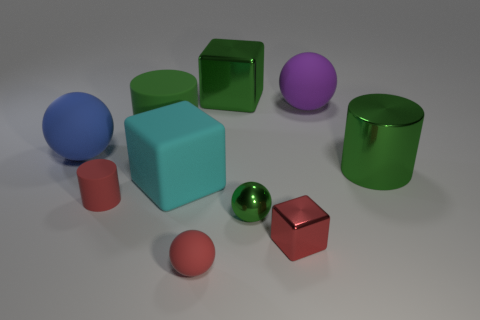Subtract all rubber blocks. How many blocks are left? 2 Subtract all gray cubes. How many green cylinders are left? 2 Subtract 1 balls. How many balls are left? 3 Subtract all blue spheres. How many spheres are left? 3 Subtract all cyan spheres. Subtract all blue cubes. How many spheres are left? 4 Subtract all balls. How many objects are left? 6 Add 8 small cylinders. How many small cylinders exist? 9 Subtract 0 brown cylinders. How many objects are left? 10 Subtract all purple spheres. Subtract all cyan rubber cylinders. How many objects are left? 9 Add 1 big green metallic cylinders. How many big green metallic cylinders are left? 2 